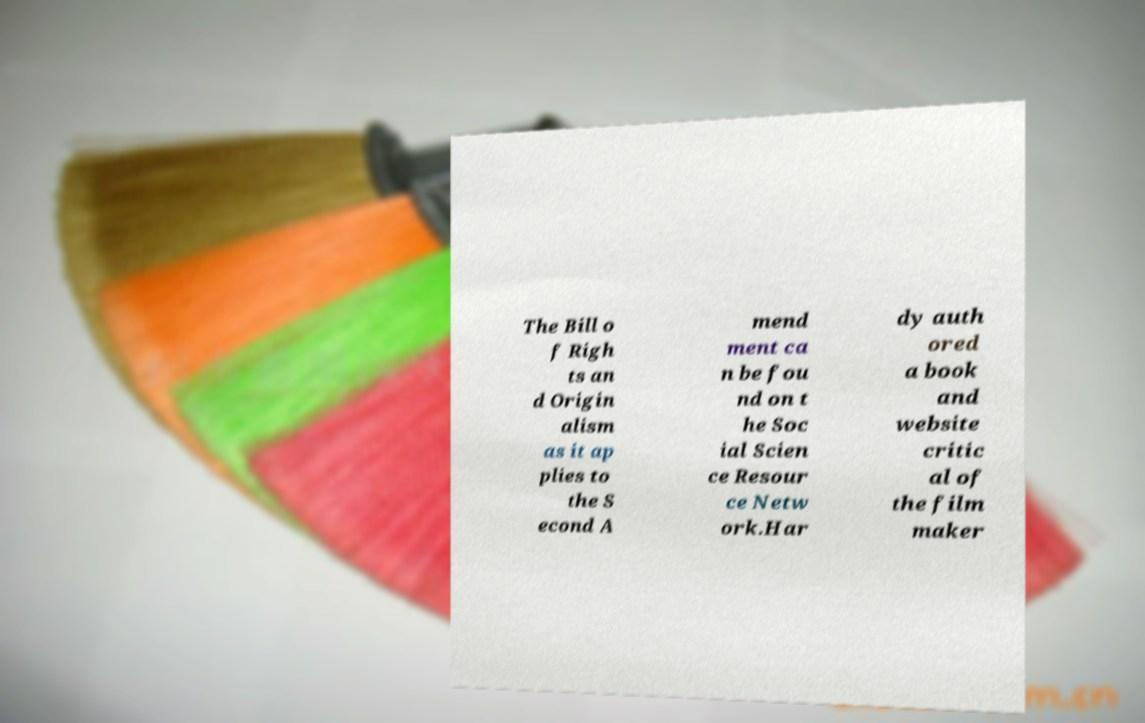There's text embedded in this image that I need extracted. Can you transcribe it verbatim? The Bill o f Righ ts an d Origin alism as it ap plies to the S econd A mend ment ca n be fou nd on t he Soc ial Scien ce Resour ce Netw ork.Har dy auth ored a book and website critic al of the film maker 